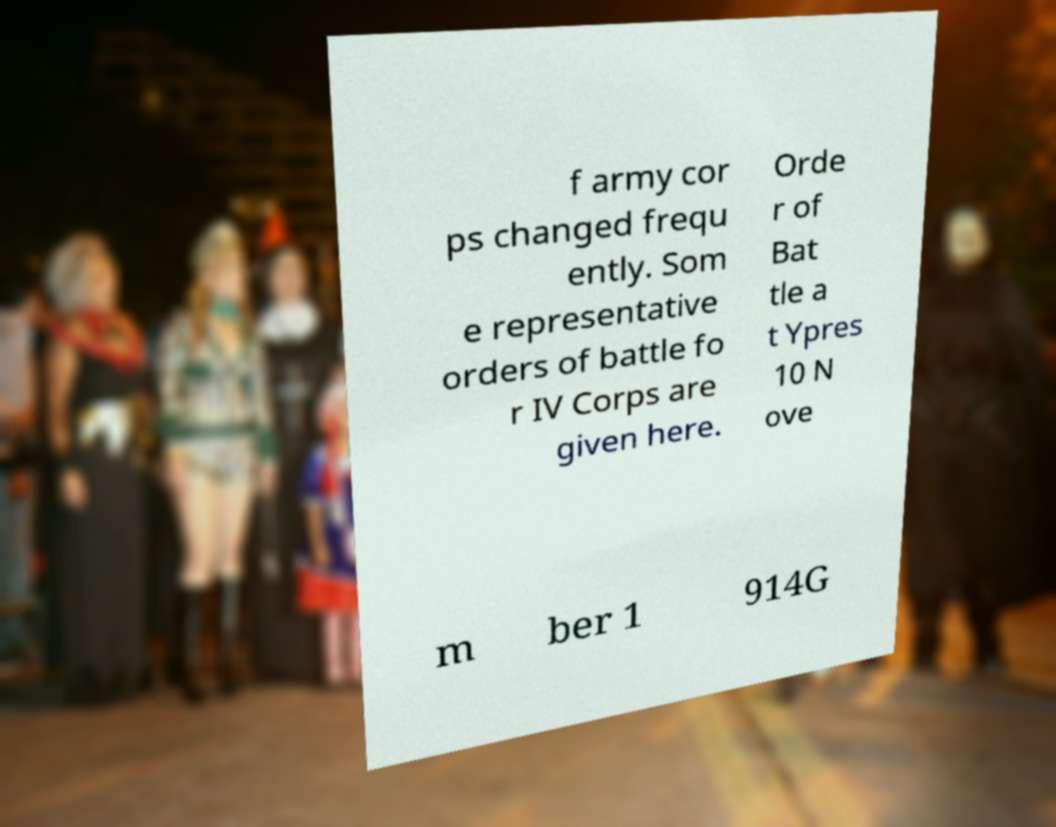Please identify and transcribe the text found in this image. f army cor ps changed frequ ently. Som e representative orders of battle fo r IV Corps are given here. Orde r of Bat tle a t Ypres 10 N ove m ber 1 914G 